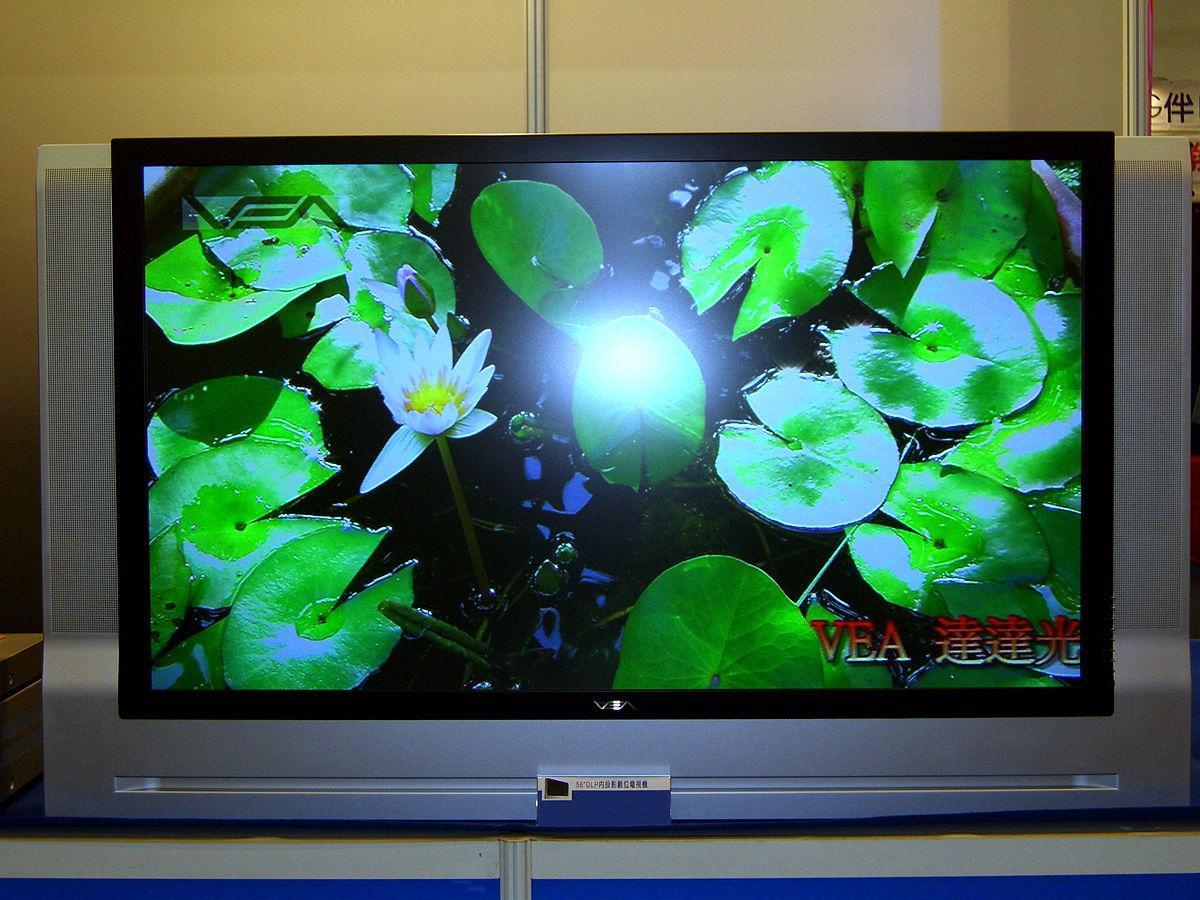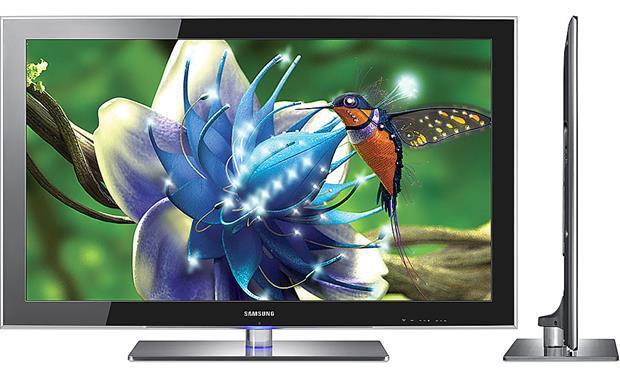The first image is the image on the left, the second image is the image on the right. For the images shown, is this caption "One of the images features a television displaying a hummingbird next to a flower." true? Answer yes or no. Yes. The first image is the image on the left, the second image is the image on the right. For the images shown, is this caption "In at least one image there is a television with a blue flower and a single hummingbird drinking from it." true? Answer yes or no. Yes. 